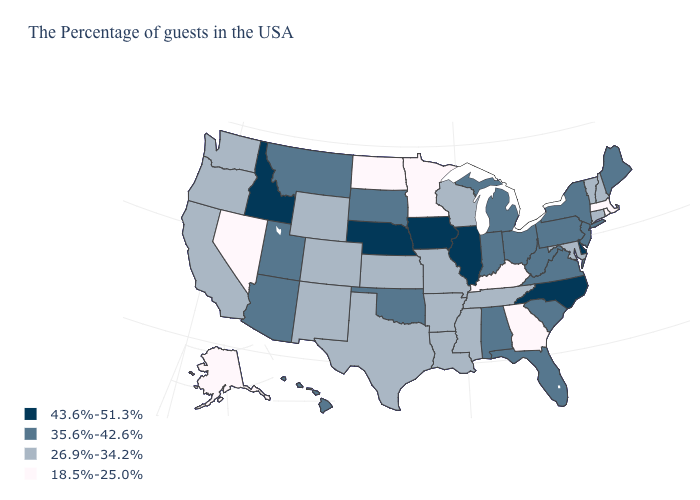Name the states that have a value in the range 43.6%-51.3%?
Answer briefly. Delaware, North Carolina, Illinois, Iowa, Nebraska, Idaho. What is the value of Alaska?
Write a very short answer. 18.5%-25.0%. Which states hav the highest value in the West?
Short answer required. Idaho. Does Nebraska have the highest value in the USA?
Write a very short answer. Yes. Name the states that have a value in the range 26.9%-34.2%?
Short answer required. New Hampshire, Vermont, Connecticut, Maryland, Tennessee, Wisconsin, Mississippi, Louisiana, Missouri, Arkansas, Kansas, Texas, Wyoming, Colorado, New Mexico, California, Washington, Oregon. Which states hav the highest value in the MidWest?
Short answer required. Illinois, Iowa, Nebraska. What is the value of Maine?
Concise answer only. 35.6%-42.6%. Does North Dakota have the lowest value in the MidWest?
Short answer required. Yes. Which states have the lowest value in the Northeast?
Give a very brief answer. Massachusetts, Rhode Island. Among the states that border Nevada , which have the highest value?
Write a very short answer. Idaho. What is the value of South Carolina?
Keep it brief. 35.6%-42.6%. Among the states that border Pennsylvania , which have the lowest value?
Keep it brief. Maryland. Name the states that have a value in the range 18.5%-25.0%?
Quick response, please. Massachusetts, Rhode Island, Georgia, Kentucky, Minnesota, North Dakota, Nevada, Alaska. Does South Dakota have the lowest value in the MidWest?
Be succinct. No. Name the states that have a value in the range 26.9%-34.2%?
Write a very short answer. New Hampshire, Vermont, Connecticut, Maryland, Tennessee, Wisconsin, Mississippi, Louisiana, Missouri, Arkansas, Kansas, Texas, Wyoming, Colorado, New Mexico, California, Washington, Oregon. 